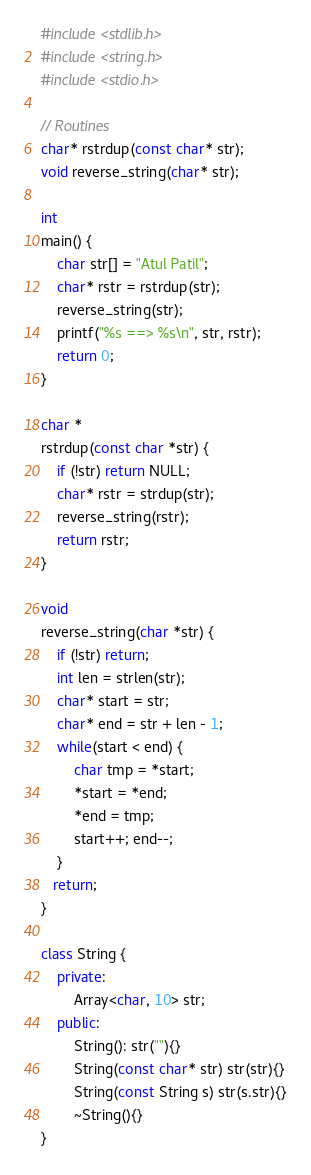Convert code to text. <code><loc_0><loc_0><loc_500><loc_500><_C++_>#include <stdlib.h>
#include <string.h>
#include <stdio.h>

// Routines
char* rstrdup(const char* str);
void reverse_string(char* str);

int 
main() {
	char str[] = "Atul Patil";
	char* rstr = rstrdup(str);
    reverse_string(str);
	printf("%s ==> %s\n", str, rstr);
	return 0;
}

char *
rstrdup(const char *str) {
	if (!str) return NULL;
	char* rstr = strdup(str);
    reverse_string(rstr);
    return rstr;
}

void
reverse_string(char *str) {
	if (!str) return;
	int len = strlen(str);
	char* start = str;
	char* end = str + len - 1;
	while(start < end) {
		char tmp = *start;
        *start = *end;
        *end = tmp;
		start++; end--;
	} 
   return;
}

class String {
	private:
		Array<char, 10> str;
    public:
		String(): str(""){}
		String(const char* str) str(str){}
		String(const String s) str(s.str){}
		~String(){}
}


</code> 